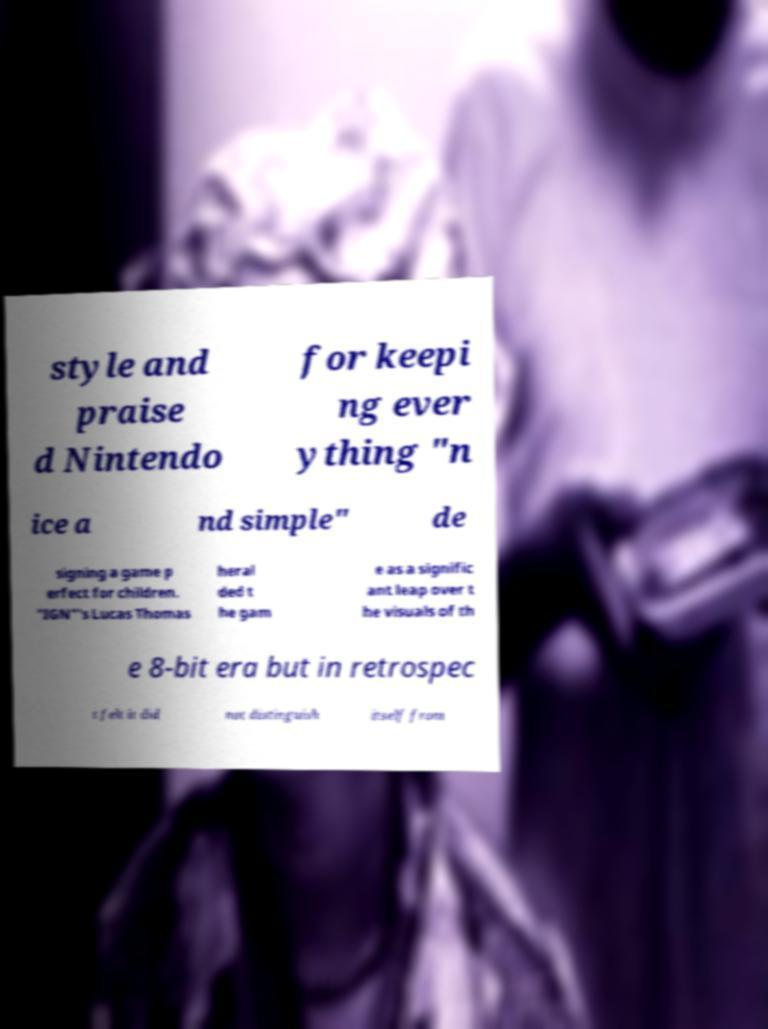Could you extract and type out the text from this image? style and praise d Nintendo for keepi ng ever ything "n ice a nd simple" de signing a game p erfect for children. "IGN"'s Lucas Thomas heral ded t he gam e as a signific ant leap over t he visuals of th e 8-bit era but in retrospec t felt it did not distinguish itself from 